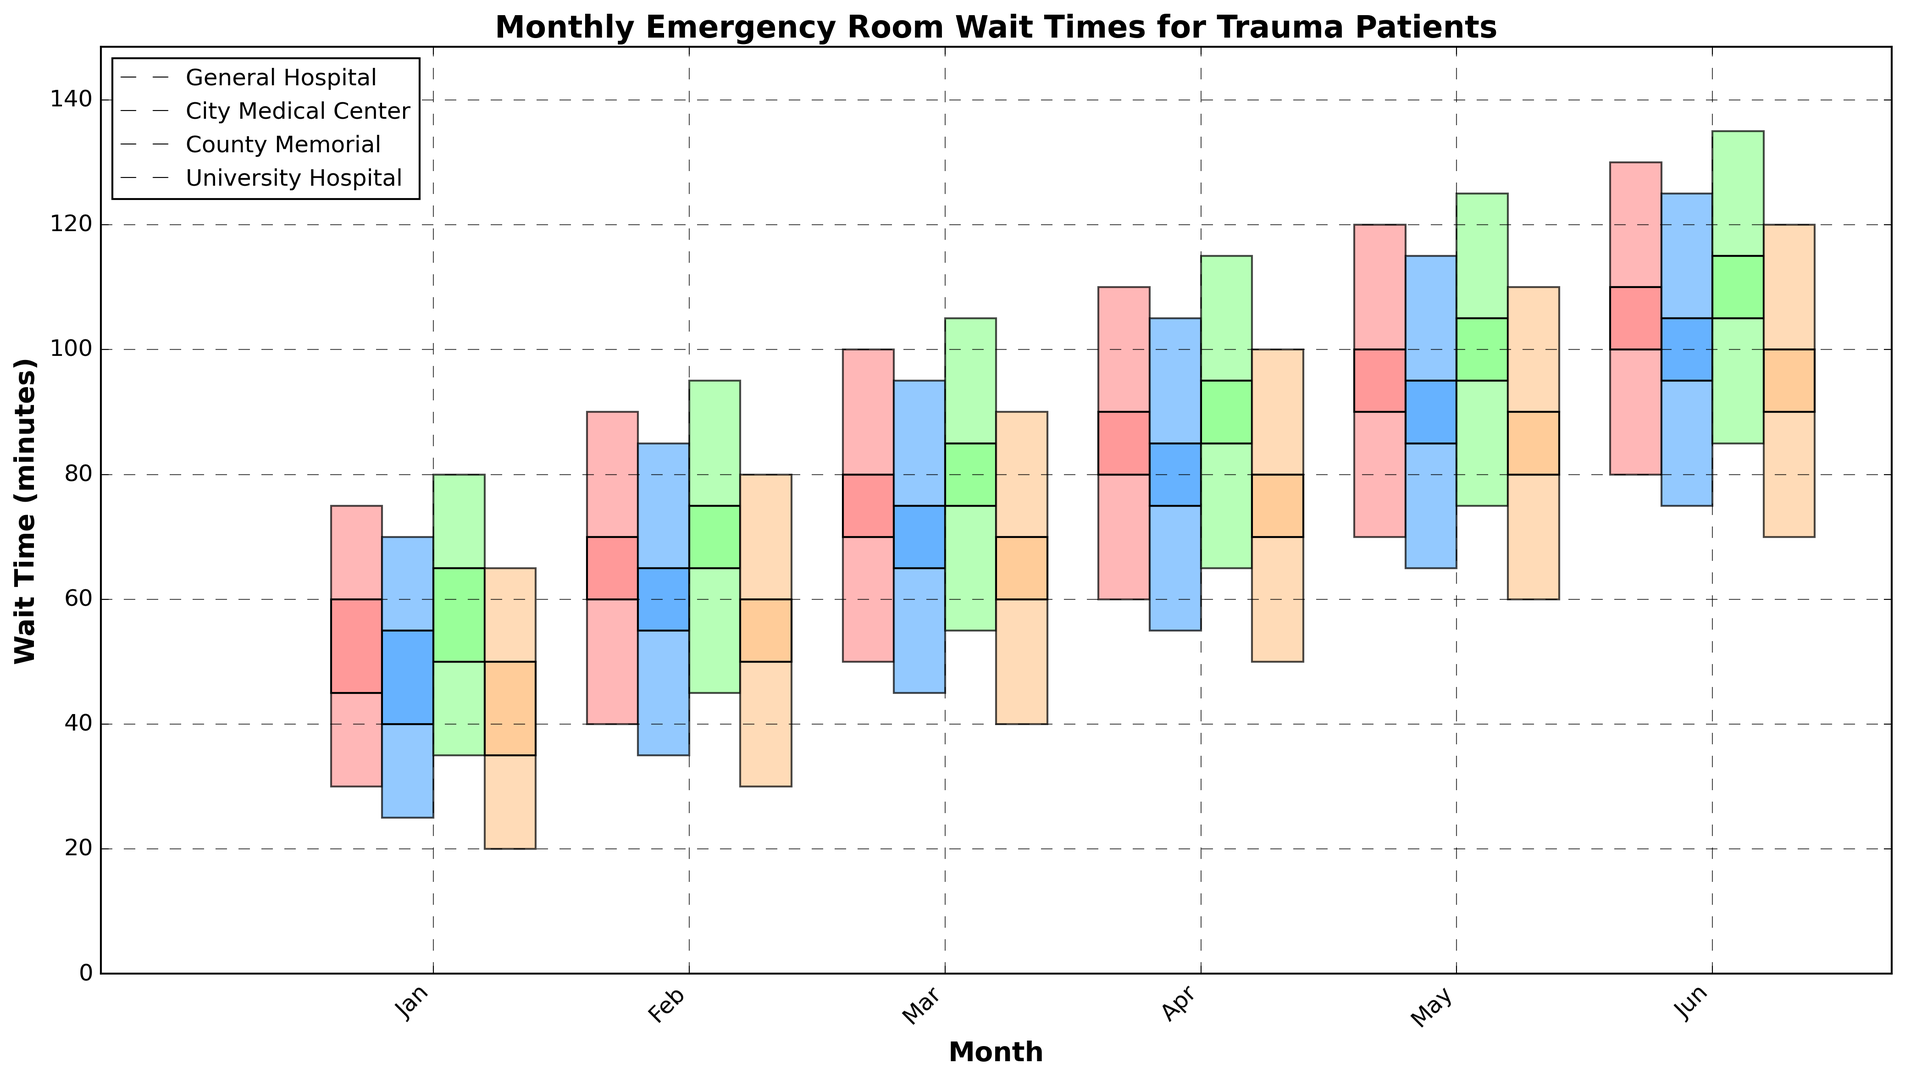What is the average closing wait time in June across all hospitals? To calculate the average closing wait time for June, sum the closing times for all hospitals and divide by the number of hospitals. The June closing wait times are 110, 105, 115, and 100. Sum these to get 430, and then divide by 4, resulting in an average of 107.5 minutes.
Answer: 107.5 minutes Which hospital had the highest peak wait time in May? To find the highest peak wait time in May, compare the high values for all hospitals. The high wait times in May are 120 for General Hospital, 115 for City Medical Center, 125 for County Memorial, and 110 for University Hospital. The highest of these is 125.
Answer: County Memorial Did any hospital have a closing wait time higher than its opening wait time in every month? For a hospital to have a closing wait time higher than its opening time in every month, look at the open and close values for each month. All hospitals have a closing time higher than the opening time every month.
Answer: Yes Which month saw the lowest opening wait time, and in which hospital? To find the lowest opening wait time, compare the opening values across all months and hospitals. The lowest opening wait time is 20 in January at University Hospital.
Answer: January, University Hospital What is the maximum difference between the high and low wait times in February across all hospitals? To find the maximum difference between high and low wait times in February, subtract the low value from the high value for each hospital. The differences are 50 (General Hospital), 50 (City Medical Center), 50 (County Memorial), and 50 (University Hospital). The maximum difference is 50.
Answer: 50 minutes 